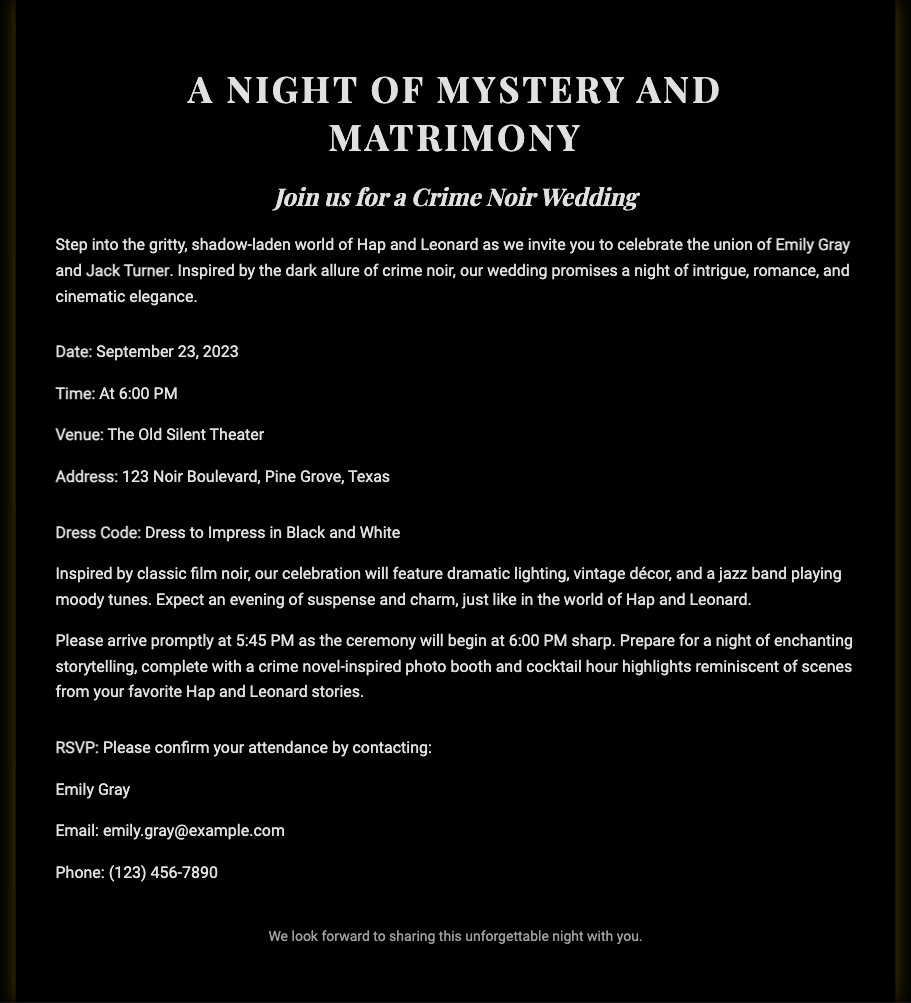What is the title of the invitation? The title of the invitation is prominently displayed at the top of the document.
Answer: A Night of Mystery and Matrimony Who are the couple getting married? The names of the couple are mentioned in the invitation paragraph.
Answer: Emily Gray and Jack Turner What is the date of the wedding? The date is clearly stated in the document under the event details.
Answer: September 23, 2023 What time does the ceremony start? The starting time for the ceremony is indicated in the invitation.
Answer: 6:00 PM What is the venue name? The venue of the wedding is specified in the details provided in the document.
Answer: The Old Silent Theater What color scheme is suggested for the dress code? The dress code description indicates the colors expected for guest attire.
Answer: Black and White Why should guests arrive by 5:45 PM? The reason for the early arrival is provided to ensure guests are on time for the ceremony.
Answer: The ceremony will begin at 6:00 PM sharp What type of music will be featured during the wedding? The type of music for the wedding is outlined in the description of the event ambiance.
Answer: Jazz band How can guests RSVP? RSVP instructions are clearly mentioned in the invitation, indicating how guests should confirm attendance.
Answer: By contacting Emily Gray via email or phone What kind of photo booth is mentioned? The thematic concept of the photo booth is specified within the celebration details.
Answer: Crime novel-inspired photo booth 